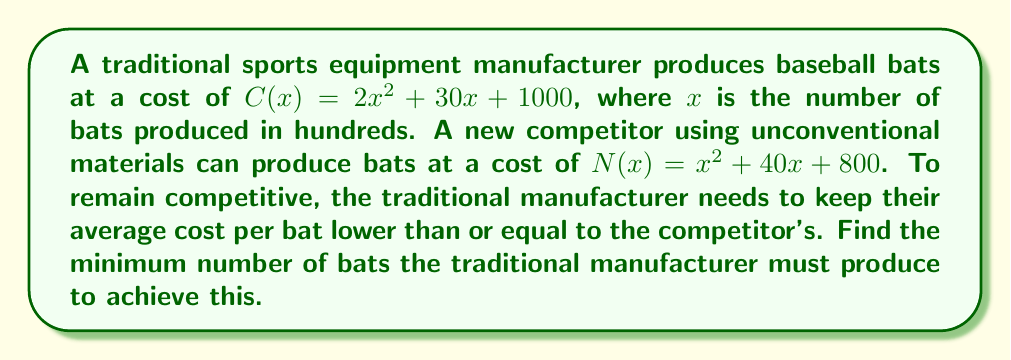Provide a solution to this math problem. 1) To find the average cost per bat, we divide the total cost by the number of bats:

   Traditional: $\frac{C(x)}{100x} = \frac{2x^2 + 30x + 1000}{100x} = \frac{2x}{100} + \frac{30}{100} + \frac{10}{x}$
   Competitor: $\frac{N(x)}{100x} = \frac{x^2 + 40x + 800}{100x} = \frac{x}{100} + \frac{40}{100} + \frac{8}{x}$

2) For the traditional manufacturer to remain competitive:

   $\frac{2x}{100} + \frac{30}{100} + \frac{10}{x} \leq \frac{x}{100} + \frac{40}{100} + \frac{8}{x}$

3) Simplify:

   $\frac{x}{100} + 0.3 + \frac{10}{x} \leq \frac{x}{100} + 0.4 + \frac{8}{x}$

4) Cancel out $\frac{x}{100}$ on both sides:

   $0.3 + \frac{10}{x} \leq 0.4 + \frac{8}{x}$

5) Subtract 0.3 from both sides:

   $\frac{10}{x} \leq 0.1 + \frac{8}{x}$

6) Subtract $\frac{8}{x}$ from both sides:

   $\frac{2}{x} \leq 0.1$

7) Multiply both sides by $x$:

   $2 \leq 0.1x$

8) Divide both sides by 0.1:

   $20 \leq x$

9) Since $x$ is in hundreds of bats, multiply by 100:

   $2000 \leq 100x$
Answer: 2000 bats 